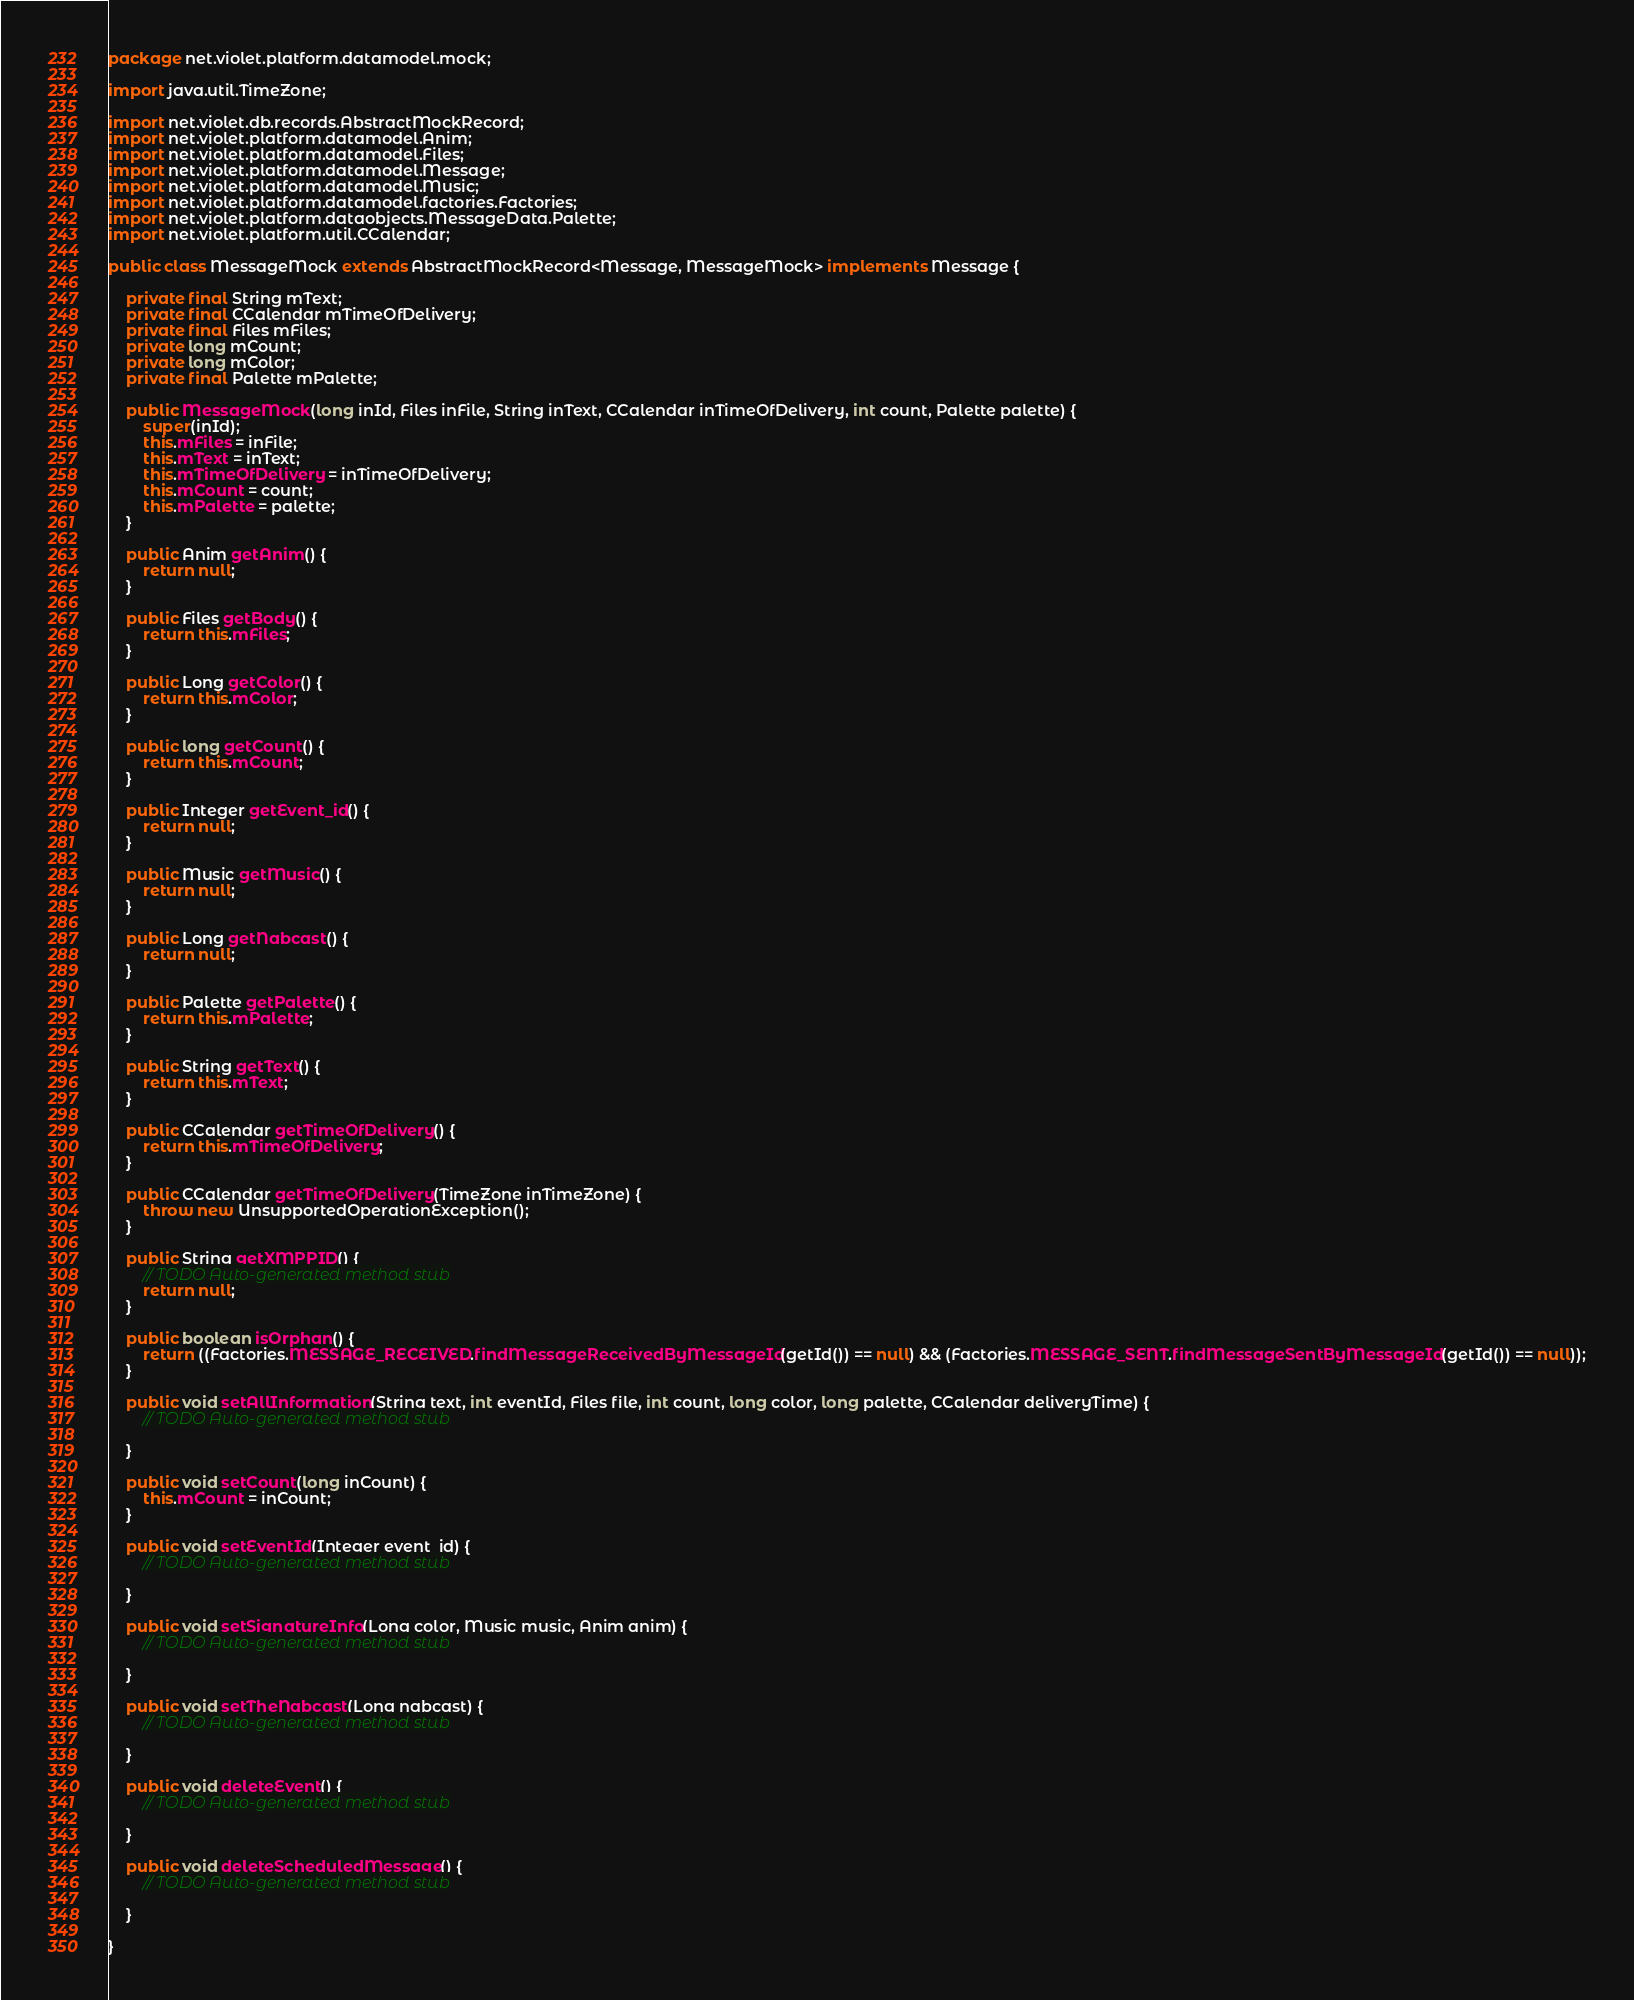<code> <loc_0><loc_0><loc_500><loc_500><_Java_>package net.violet.platform.datamodel.mock;

import java.util.TimeZone;

import net.violet.db.records.AbstractMockRecord;
import net.violet.platform.datamodel.Anim;
import net.violet.platform.datamodel.Files;
import net.violet.platform.datamodel.Message;
import net.violet.platform.datamodel.Music;
import net.violet.platform.datamodel.factories.Factories;
import net.violet.platform.dataobjects.MessageData.Palette;
import net.violet.platform.util.CCalendar;

public class MessageMock extends AbstractMockRecord<Message, MessageMock> implements Message {

	private final String mText;
	private final CCalendar mTimeOfDelivery;
	private final Files mFiles;
	private long mCount;
	private long mColor;
	private final Palette mPalette;

	public MessageMock(long inId, Files inFile, String inText, CCalendar inTimeOfDelivery, int count, Palette palette) {
		super(inId);
		this.mFiles = inFile;
		this.mText = inText;
		this.mTimeOfDelivery = inTimeOfDelivery;
		this.mCount = count;
		this.mPalette = palette;
	}

	public Anim getAnim() {
		return null;
	}

	public Files getBody() {
		return this.mFiles;
	}

	public Long getColor() {
		return this.mColor;
	}

	public long getCount() {
		return this.mCount;
	}

	public Integer getEvent_id() {
		return null;
	}

	public Music getMusic() {
		return null;
	}

	public Long getNabcast() {
		return null;
	}

	public Palette getPalette() {
		return this.mPalette;
	}

	public String getText() {
		return this.mText;
	}

	public CCalendar getTimeOfDelivery() {
		return this.mTimeOfDelivery;
	}

	public CCalendar getTimeOfDelivery(TimeZone inTimeZone) {
		throw new UnsupportedOperationException();
	}

	public String getXMPPID() {
		// TODO Auto-generated method stub
		return null;
	}

	public boolean isOrphan() {
		return ((Factories.MESSAGE_RECEIVED.findMessageReceivedByMessageId(getId()) == null) && (Factories.MESSAGE_SENT.findMessageSentByMessageId(getId()) == null));
	}

	public void setAllInformation(String text, int eventId, Files file, int count, long color, long palette, CCalendar deliveryTime) {
		// TODO Auto-generated method stub

	}

	public void setCount(long inCount) {
		this.mCount = inCount;
	}

	public void setEventId(Integer event_id) {
		// TODO Auto-generated method stub

	}

	public void setSignatureInfo(Long color, Music music, Anim anim) {
		// TODO Auto-generated method stub

	}

	public void setTheNabcast(Long nabcast) {
		// TODO Auto-generated method stub

	}

	public void deleteEvent() {
		// TODO Auto-generated method stub

	}

	public void deleteScheduledMessage() {
		// TODO Auto-generated method stub

	}

}
</code> 